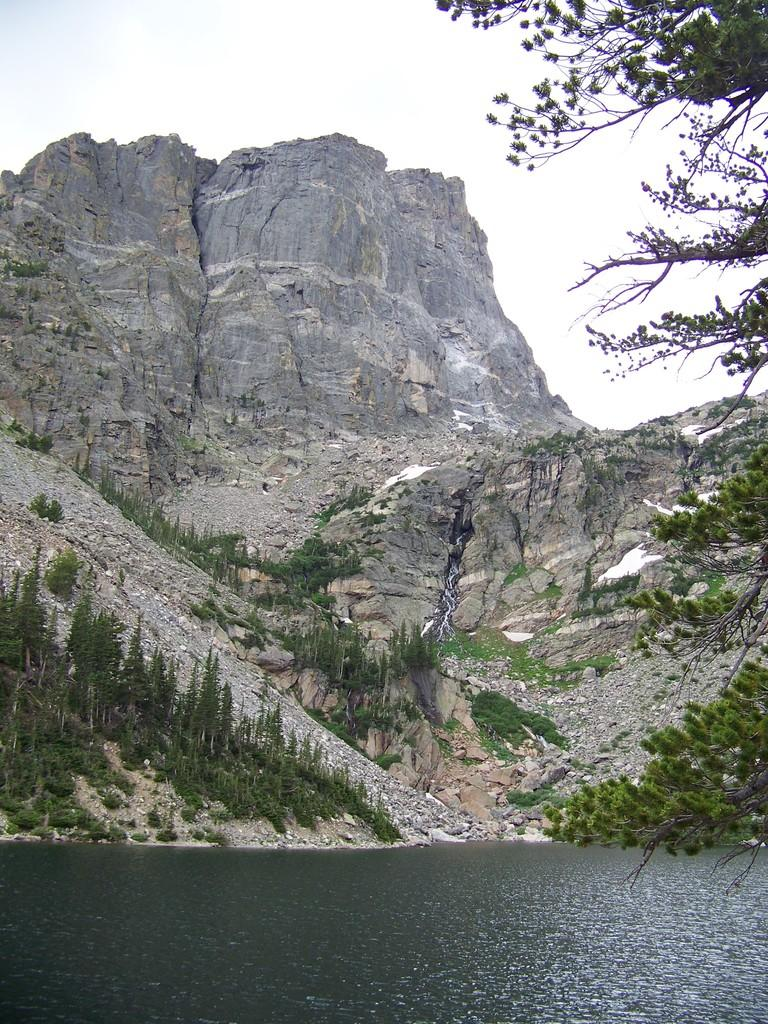What type of natural feature can be seen in the image? There is a river in the image. What other natural elements are present in the image? There are trees and a hill in the image. What is visible in the background of the image? The sky is visible in the image. What type of fruit can be seen hanging from the trees in the image? There is no fruit visible in the image; only trees are present. What type of coil is wrapped around the hill in the image? There is no coil present in the image; only a hill is visible. 